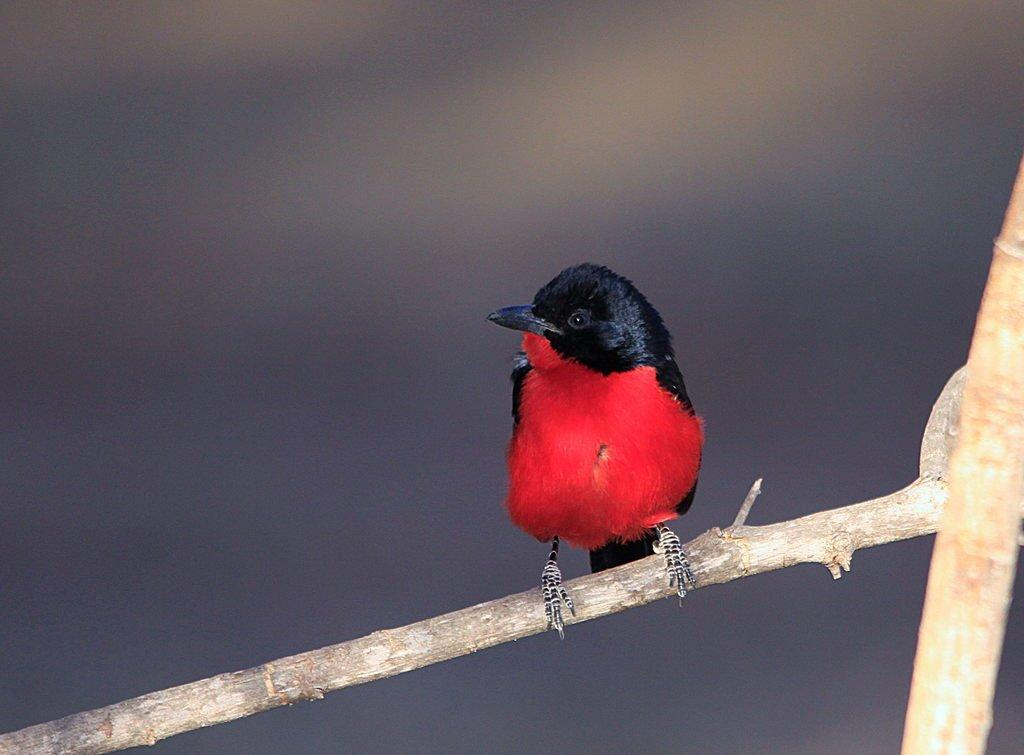What type of animal is in the image? There is a bird in the image. Where is the bird located? The bird is on a branch. Can you describe the background of the image? The background of the image is blurry. What process is the cub going through during this week in the image? There is no cub or any indication of a process or a specific week in the image; it features a bird on a branch with a blurry background. 